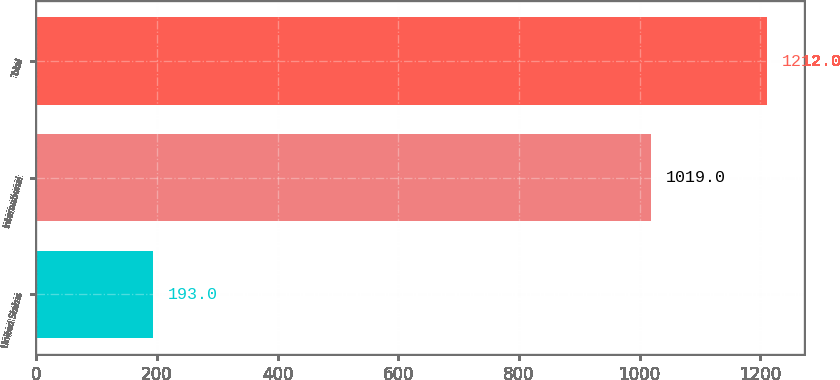<chart> <loc_0><loc_0><loc_500><loc_500><bar_chart><fcel>United States<fcel>International<fcel>Total<nl><fcel>193<fcel>1019<fcel>1212<nl></chart> 